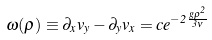<formula> <loc_0><loc_0><loc_500><loc_500>\omega ( \rho ) \equiv \partial _ { x } v _ { y } - \partial _ { y } v _ { x } = c e ^ { - 2 \frac { g \rho ^ { 2 } } { 3 \nu } }</formula> 